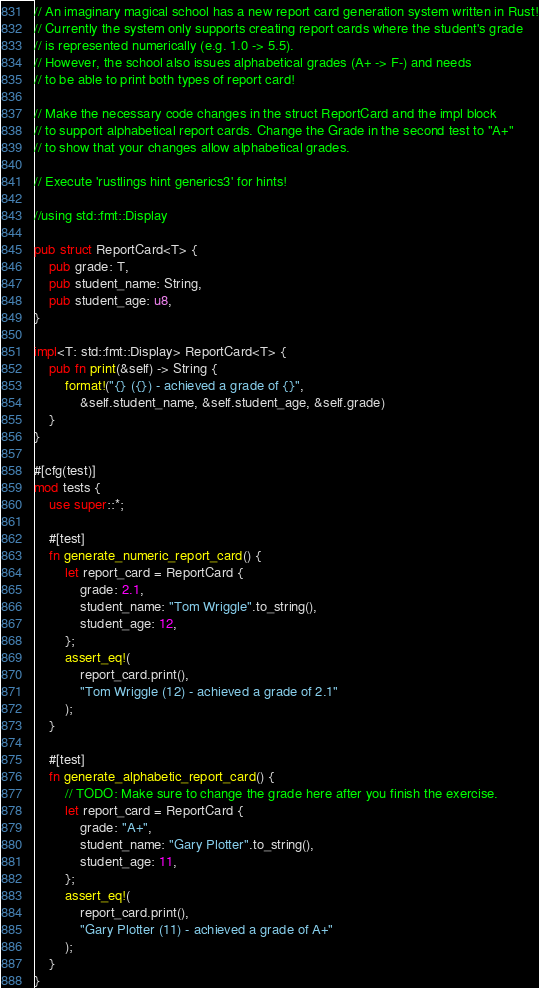Convert code to text. <code><loc_0><loc_0><loc_500><loc_500><_Rust_>// An imaginary magical school has a new report card generation system written in Rust!
// Currently the system only supports creating report cards where the student's grade
// is represented numerically (e.g. 1.0 -> 5.5).
// However, the school also issues alphabetical grades (A+ -> F-) and needs
// to be able to print both types of report card!

// Make the necessary code changes in the struct ReportCard and the impl block
// to support alphabetical report cards. Change the Grade in the second test to "A+"
// to show that your changes allow alphabetical grades.

// Execute 'rustlings hint generics3' for hints!

//using std::fmt::Display

pub struct ReportCard<T> {
    pub grade: T,
    pub student_name: String,
    pub student_age: u8,
}

impl<T: std::fmt::Display> ReportCard<T> {
    pub fn print(&self) -> String {
        format!("{} ({}) - achieved a grade of {}",
            &self.student_name, &self.student_age, &self.grade)
    }
}

#[cfg(test)]
mod tests {
    use super::*;

    #[test]
    fn generate_numeric_report_card() {
        let report_card = ReportCard {
            grade: 2.1,
            student_name: "Tom Wriggle".to_string(),
            student_age: 12,
        };
        assert_eq!(
            report_card.print(),
            "Tom Wriggle (12) - achieved a grade of 2.1"
        );
    }

    #[test]
    fn generate_alphabetic_report_card() {
        // TODO: Make sure to change the grade here after you finish the exercise.
        let report_card = ReportCard {
            grade: "A+",
            student_name: "Gary Plotter".to_string(),
            student_age: 11,
        };
        assert_eq!(
            report_card.print(),
            "Gary Plotter (11) - achieved a grade of A+"
        );
    }
}
</code> 